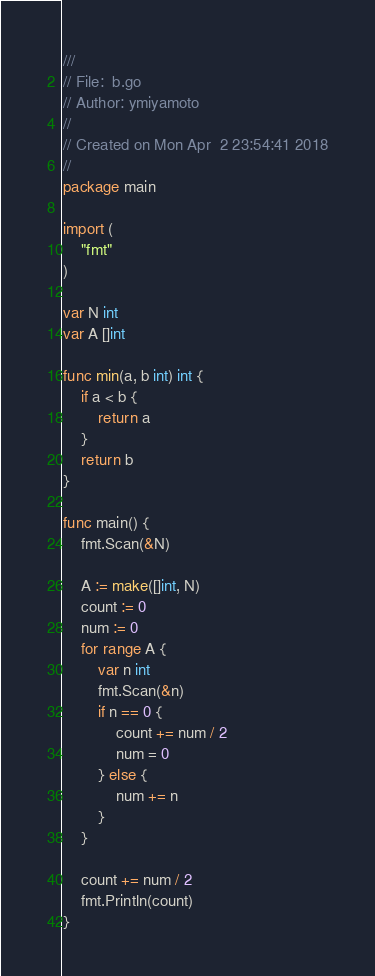Convert code to text. <code><loc_0><loc_0><loc_500><loc_500><_Go_>///
// File:  b.go
// Author: ymiyamoto
//
// Created on Mon Apr  2 23:54:41 2018
//
package main

import (
	"fmt"
)

var N int
var A []int

func min(a, b int) int {
	if a < b {
		return a
	}
	return b
}

func main() {
	fmt.Scan(&N)

	A := make([]int, N)
	count := 0
	num := 0
	for range A {
		var n int
		fmt.Scan(&n)
		if n == 0 {
			count += num / 2
			num = 0
		} else {
			num += n
		}
	}

	count += num / 2
	fmt.Println(count)
}
</code> 